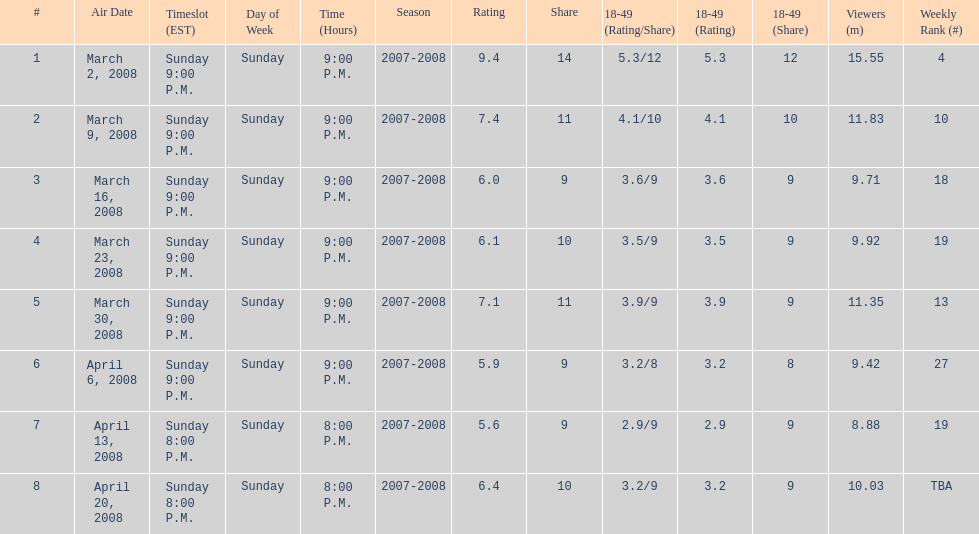Did the season finish at an earlier or later timeslot? Earlier. 